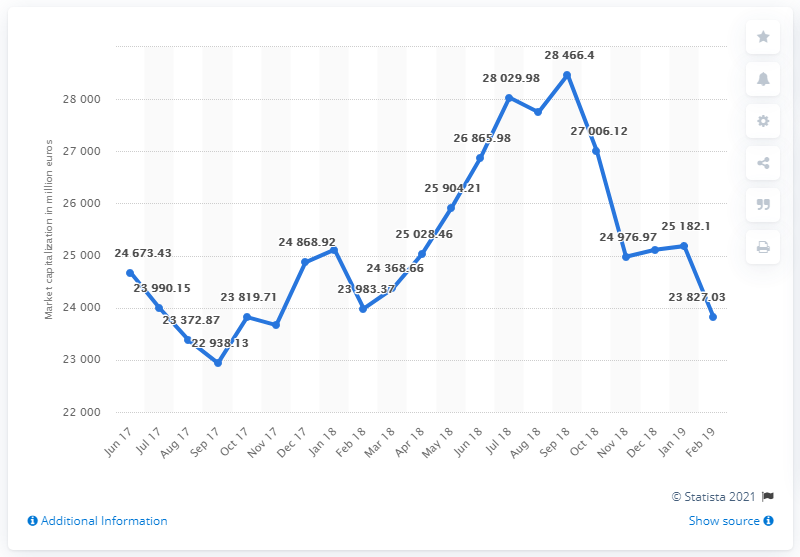Draw attention to some important aspects in this diagram. As of February 28, 2019, the market value of Luxottica Group's outstanding shares was 23,827.03. 